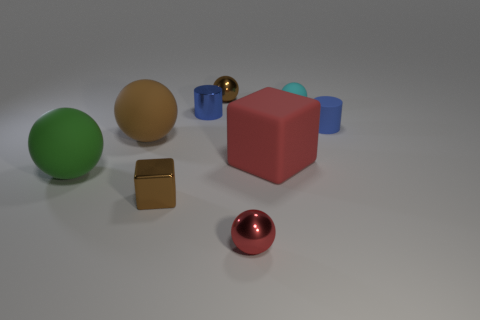There is a brown cube that is the same size as the metallic cylinder; what is it made of? The object you're referring to appears to be a cube with a brownish hue, which could suggest it is made of wood or has a wood-like texture. However, without tactile or additional visual cues, we cannot determine the exact material with certainty just from this image. 